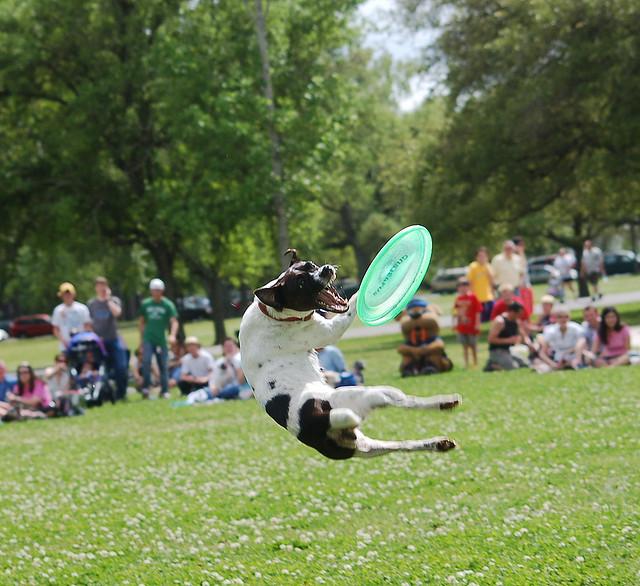Is the dog's mouth open?
Quick response, please. Yes. Is the dog playing with someone?
Quick response, please. Yes. What is the dog trying to catch?
Quick response, please. Frisbee. What is the color of the frisbee?
Quick response, please. Green. 